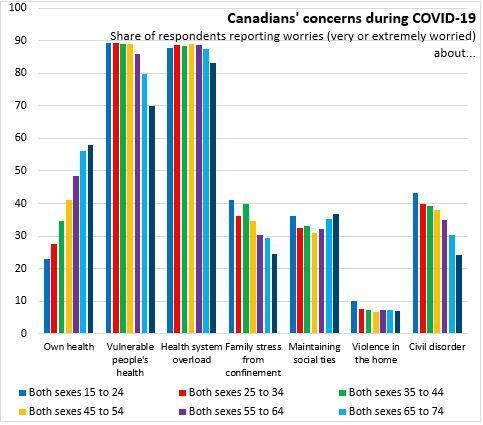What is the number of people worried about the civil disorder of both sexes 55 to 64?
Answer the question with a short phrase. 35 What is the number of respondents worried about own health of both sexes 35 to 44? 35 